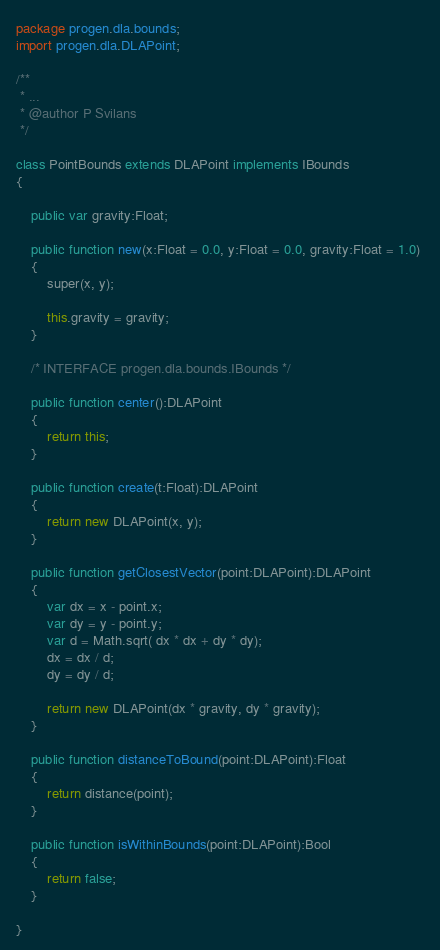<code> <loc_0><loc_0><loc_500><loc_500><_Haxe_>package progen.dla.bounds;
import progen.dla.DLAPoint;

/**
 * ...
 * @author P Svilans
 */

class PointBounds extends DLAPoint implements IBounds
{
	
	public var gravity:Float;

	public function new(x:Float = 0.0, y:Float = 0.0, gravity:Float = 1.0) 
	{
		super(x, y);
		
		this.gravity = gravity;
	}
	
	/* INTERFACE progen.dla.bounds.IBounds */
	
	public function center():DLAPoint
	{
		return this;
	}
	
	public function create(t:Float):DLAPoint 
	{
		return new DLAPoint(x, y);
	}
	
	public function getClosestVector(point:DLAPoint):DLAPoint
	{
		var dx = x - point.x;
		var dy = y - point.y;
		var d = Math.sqrt( dx * dx + dy * dy);
		dx = dx / d;
		dy = dy / d;
		
		return new DLAPoint(dx * gravity, dy * gravity);
	}
	
	public function distanceToBound(point:DLAPoint):Float 
	{
		return distance(point);
	}
	
	public function isWithinBounds(point:DLAPoint):Bool
	{
		return false;
	}
	
}</code> 